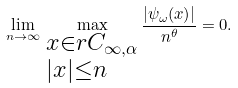Convert formula to latex. <formula><loc_0><loc_0><loc_500><loc_500>\lim _ { n \to \infty } \, \max _ { \begin{subarray} { c } x \in r C _ { \infty , \alpha } \\ | x | \leq n \end{subarray} } \frac { | \psi _ { \omega } ( x ) | } { n ^ { \theta } } = 0 .</formula> 